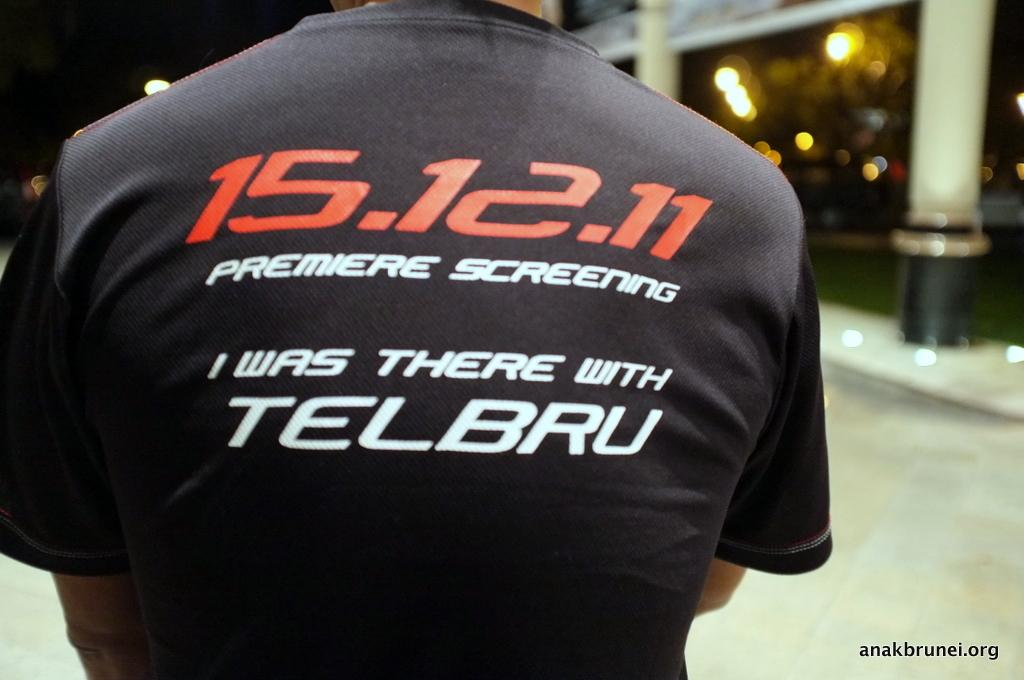<image>
Offer a succinct explanation of the picture presented. a person wearing a shirt that says 'I was there with telbru' on it 